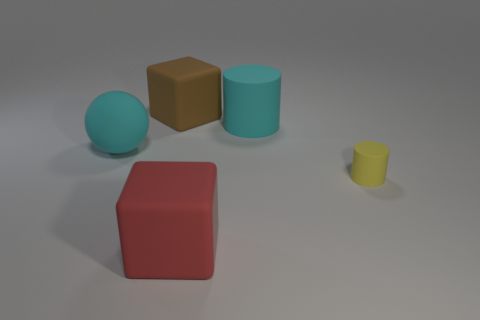Are there any other things that have the same size as the yellow cylinder?
Give a very brief answer. No. Is the shape of the large cyan thing to the right of the brown matte cube the same as the small rubber thing that is in front of the big brown object?
Offer a terse response. Yes. What is the shape of the brown rubber object that is the same size as the ball?
Your answer should be very brief. Cube. What number of metal objects are small purple blocks or brown blocks?
Provide a short and direct response. 0. Is the material of the big thing in front of the cyan matte ball the same as the large cyan thing in front of the big cyan rubber cylinder?
Offer a terse response. Yes. What color is the small cylinder that is made of the same material as the large sphere?
Make the answer very short. Yellow. Are there more large blocks in front of the tiny matte object than small rubber cylinders behind the big rubber cylinder?
Provide a succinct answer. Yes. Is there a large purple rubber thing?
Provide a short and direct response. No. What material is the cylinder that is the same color as the sphere?
Keep it short and to the point. Rubber. How many things are small matte cylinders or big brown matte balls?
Provide a short and direct response. 1. 